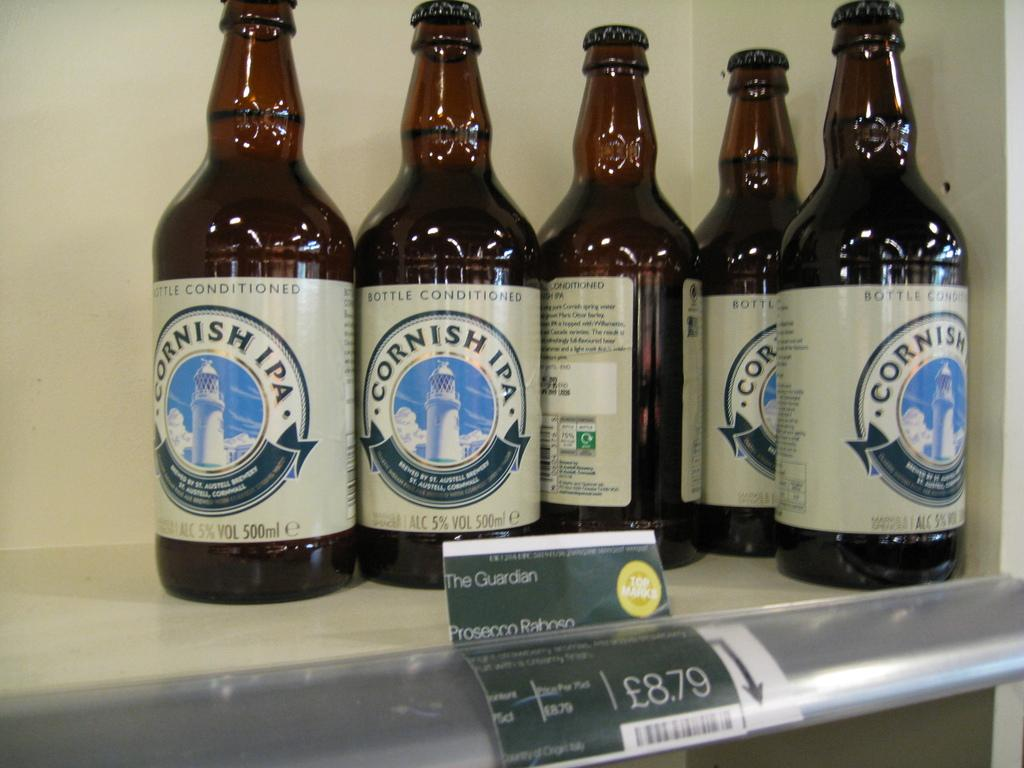How many bottles are visible in the image? There are five bottles in the image. What type of secretary can be seen working in the image? There is no secretary present in the image; it only features five bottles. What shape are the bottles in the image? The provided facts do not mention the shape of the bottles, so we cannot determine their shape from the image. 